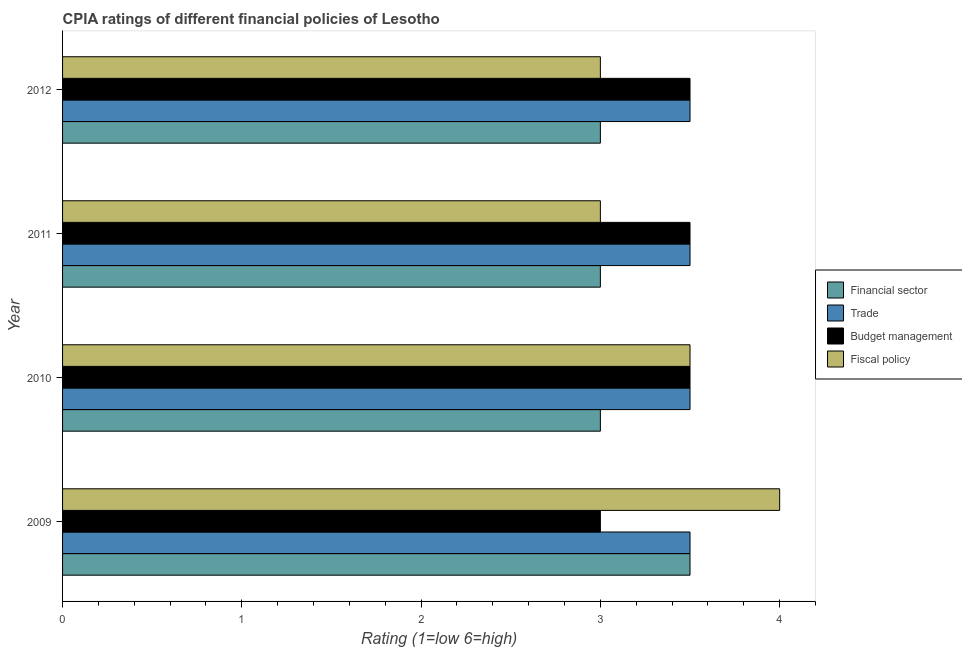How many different coloured bars are there?
Give a very brief answer. 4. How many groups of bars are there?
Your response must be concise. 4. Are the number of bars on each tick of the Y-axis equal?
Ensure brevity in your answer.  Yes. How many bars are there on the 2nd tick from the top?
Keep it short and to the point. 4. How many bars are there on the 1st tick from the bottom?
Provide a succinct answer. 4. In how many cases, is the number of bars for a given year not equal to the number of legend labels?
Offer a very short reply. 0. What is the cpia rating of trade in 2009?
Give a very brief answer. 3.5. Across all years, what is the maximum cpia rating of trade?
Offer a very short reply. 3.5. What is the difference between the cpia rating of financial sector in 2010 and that in 2011?
Provide a succinct answer. 0. What is the difference between the cpia rating of financial sector in 2009 and the cpia rating of trade in 2010?
Provide a short and direct response. 0. What is the average cpia rating of fiscal policy per year?
Provide a succinct answer. 3.38. What is the ratio of the cpia rating of fiscal policy in 2009 to that in 2010?
Ensure brevity in your answer.  1.14. Is the cpia rating of budget management in 2010 less than that in 2011?
Keep it short and to the point. No. In how many years, is the cpia rating of fiscal policy greater than the average cpia rating of fiscal policy taken over all years?
Your answer should be compact. 2. Is the sum of the cpia rating of fiscal policy in 2009 and 2011 greater than the maximum cpia rating of financial sector across all years?
Provide a succinct answer. Yes. Is it the case that in every year, the sum of the cpia rating of financial sector and cpia rating of fiscal policy is greater than the sum of cpia rating of budget management and cpia rating of trade?
Provide a succinct answer. No. What does the 3rd bar from the top in 2010 represents?
Your answer should be very brief. Trade. What does the 3rd bar from the bottom in 2011 represents?
Give a very brief answer. Budget management. How many bars are there?
Keep it short and to the point. 16. How many years are there in the graph?
Give a very brief answer. 4. Does the graph contain any zero values?
Your answer should be compact. No. What is the title of the graph?
Your response must be concise. CPIA ratings of different financial policies of Lesotho. Does "Primary education" appear as one of the legend labels in the graph?
Give a very brief answer. No. What is the label or title of the Y-axis?
Give a very brief answer. Year. What is the Rating (1=low 6=high) in Financial sector in 2009?
Give a very brief answer. 3.5. What is the Rating (1=low 6=high) of Trade in 2009?
Offer a very short reply. 3.5. What is the Rating (1=low 6=high) in Budget management in 2009?
Keep it short and to the point. 3. What is the Rating (1=low 6=high) in Financial sector in 2010?
Offer a very short reply. 3. What is the Rating (1=low 6=high) in Trade in 2010?
Offer a terse response. 3.5. What is the Rating (1=low 6=high) of Budget management in 2010?
Provide a succinct answer. 3.5. What is the Rating (1=low 6=high) in Financial sector in 2011?
Provide a short and direct response. 3. What is the Rating (1=low 6=high) in Budget management in 2011?
Offer a very short reply. 3.5. What is the Rating (1=low 6=high) of Financial sector in 2012?
Provide a succinct answer. 3. What is the Rating (1=low 6=high) in Trade in 2012?
Your answer should be compact. 3.5. Across all years, what is the maximum Rating (1=low 6=high) of Trade?
Make the answer very short. 3.5. Across all years, what is the maximum Rating (1=low 6=high) of Fiscal policy?
Keep it short and to the point. 4. Across all years, what is the minimum Rating (1=low 6=high) in Financial sector?
Offer a very short reply. 3. Across all years, what is the minimum Rating (1=low 6=high) in Trade?
Offer a very short reply. 3.5. Across all years, what is the minimum Rating (1=low 6=high) in Fiscal policy?
Your answer should be very brief. 3. What is the total Rating (1=low 6=high) in Budget management in the graph?
Give a very brief answer. 13.5. What is the total Rating (1=low 6=high) of Fiscal policy in the graph?
Give a very brief answer. 13.5. What is the difference between the Rating (1=low 6=high) in Trade in 2009 and that in 2010?
Ensure brevity in your answer.  0. What is the difference between the Rating (1=low 6=high) of Budget management in 2009 and that in 2010?
Ensure brevity in your answer.  -0.5. What is the difference between the Rating (1=low 6=high) in Fiscal policy in 2009 and that in 2011?
Make the answer very short. 1. What is the difference between the Rating (1=low 6=high) in Trade in 2009 and that in 2012?
Make the answer very short. 0. What is the difference between the Rating (1=low 6=high) of Budget management in 2009 and that in 2012?
Your answer should be very brief. -0.5. What is the difference between the Rating (1=low 6=high) in Financial sector in 2010 and that in 2011?
Keep it short and to the point. 0. What is the difference between the Rating (1=low 6=high) of Fiscal policy in 2010 and that in 2011?
Your response must be concise. 0.5. What is the difference between the Rating (1=low 6=high) in Trade in 2010 and that in 2012?
Provide a short and direct response. 0. What is the difference between the Rating (1=low 6=high) of Budget management in 2010 and that in 2012?
Keep it short and to the point. 0. What is the difference between the Rating (1=low 6=high) of Financial sector in 2011 and that in 2012?
Keep it short and to the point. 0. What is the difference between the Rating (1=low 6=high) of Trade in 2011 and that in 2012?
Offer a terse response. 0. What is the difference between the Rating (1=low 6=high) in Budget management in 2011 and that in 2012?
Keep it short and to the point. 0. What is the difference between the Rating (1=low 6=high) in Financial sector in 2009 and the Rating (1=low 6=high) in Budget management in 2010?
Keep it short and to the point. 0. What is the difference between the Rating (1=low 6=high) in Trade in 2009 and the Rating (1=low 6=high) in Budget management in 2010?
Ensure brevity in your answer.  0. What is the difference between the Rating (1=low 6=high) of Trade in 2009 and the Rating (1=low 6=high) of Budget management in 2011?
Your answer should be compact. 0. What is the difference between the Rating (1=low 6=high) in Trade in 2009 and the Rating (1=low 6=high) in Fiscal policy in 2011?
Your answer should be very brief. 0.5. What is the difference between the Rating (1=low 6=high) of Budget management in 2009 and the Rating (1=low 6=high) of Fiscal policy in 2011?
Ensure brevity in your answer.  0. What is the difference between the Rating (1=low 6=high) of Financial sector in 2009 and the Rating (1=low 6=high) of Trade in 2012?
Provide a succinct answer. 0. What is the difference between the Rating (1=low 6=high) in Financial sector in 2009 and the Rating (1=low 6=high) in Budget management in 2012?
Provide a short and direct response. 0. What is the difference between the Rating (1=low 6=high) in Financial sector in 2009 and the Rating (1=low 6=high) in Fiscal policy in 2012?
Provide a short and direct response. 0.5. What is the difference between the Rating (1=low 6=high) in Trade in 2009 and the Rating (1=low 6=high) in Budget management in 2012?
Provide a short and direct response. 0. What is the difference between the Rating (1=low 6=high) of Trade in 2009 and the Rating (1=low 6=high) of Fiscal policy in 2012?
Keep it short and to the point. 0.5. What is the difference between the Rating (1=low 6=high) in Budget management in 2009 and the Rating (1=low 6=high) in Fiscal policy in 2012?
Keep it short and to the point. 0. What is the difference between the Rating (1=low 6=high) of Trade in 2010 and the Rating (1=low 6=high) of Budget management in 2011?
Make the answer very short. 0. What is the difference between the Rating (1=low 6=high) in Financial sector in 2010 and the Rating (1=low 6=high) in Budget management in 2012?
Your response must be concise. -0.5. What is the difference between the Rating (1=low 6=high) of Financial sector in 2010 and the Rating (1=low 6=high) of Fiscal policy in 2012?
Ensure brevity in your answer.  0. What is the difference between the Rating (1=low 6=high) of Trade in 2010 and the Rating (1=low 6=high) of Budget management in 2012?
Make the answer very short. 0. What is the difference between the Rating (1=low 6=high) of Trade in 2010 and the Rating (1=low 6=high) of Fiscal policy in 2012?
Ensure brevity in your answer.  0.5. What is the difference between the Rating (1=low 6=high) of Financial sector in 2011 and the Rating (1=low 6=high) of Trade in 2012?
Make the answer very short. -0.5. What is the difference between the Rating (1=low 6=high) in Financial sector in 2011 and the Rating (1=low 6=high) in Budget management in 2012?
Provide a succinct answer. -0.5. What is the difference between the Rating (1=low 6=high) of Budget management in 2011 and the Rating (1=low 6=high) of Fiscal policy in 2012?
Your answer should be compact. 0.5. What is the average Rating (1=low 6=high) of Financial sector per year?
Provide a short and direct response. 3.12. What is the average Rating (1=low 6=high) of Trade per year?
Ensure brevity in your answer.  3.5. What is the average Rating (1=low 6=high) in Budget management per year?
Provide a succinct answer. 3.38. What is the average Rating (1=low 6=high) in Fiscal policy per year?
Make the answer very short. 3.38. In the year 2009, what is the difference between the Rating (1=low 6=high) of Financial sector and Rating (1=low 6=high) of Trade?
Give a very brief answer. 0. In the year 2009, what is the difference between the Rating (1=low 6=high) in Financial sector and Rating (1=low 6=high) in Budget management?
Your answer should be compact. 0.5. In the year 2009, what is the difference between the Rating (1=low 6=high) of Trade and Rating (1=low 6=high) of Budget management?
Your response must be concise. 0.5. In the year 2009, what is the difference between the Rating (1=low 6=high) in Trade and Rating (1=low 6=high) in Fiscal policy?
Give a very brief answer. -0.5. In the year 2010, what is the difference between the Rating (1=low 6=high) of Trade and Rating (1=low 6=high) of Budget management?
Give a very brief answer. 0. In the year 2010, what is the difference between the Rating (1=low 6=high) in Trade and Rating (1=low 6=high) in Fiscal policy?
Offer a terse response. 0. In the year 2010, what is the difference between the Rating (1=low 6=high) of Budget management and Rating (1=low 6=high) of Fiscal policy?
Make the answer very short. 0. In the year 2011, what is the difference between the Rating (1=low 6=high) of Financial sector and Rating (1=low 6=high) of Fiscal policy?
Keep it short and to the point. 0. In the year 2012, what is the difference between the Rating (1=low 6=high) of Financial sector and Rating (1=low 6=high) of Trade?
Ensure brevity in your answer.  -0.5. In the year 2012, what is the difference between the Rating (1=low 6=high) in Trade and Rating (1=low 6=high) in Fiscal policy?
Give a very brief answer. 0.5. In the year 2012, what is the difference between the Rating (1=low 6=high) of Budget management and Rating (1=low 6=high) of Fiscal policy?
Your answer should be very brief. 0.5. What is the ratio of the Rating (1=low 6=high) of Trade in 2009 to that in 2010?
Give a very brief answer. 1. What is the ratio of the Rating (1=low 6=high) of Budget management in 2009 to that in 2011?
Your answer should be compact. 0.86. What is the ratio of the Rating (1=low 6=high) in Financial sector in 2009 to that in 2012?
Your answer should be compact. 1.17. What is the ratio of the Rating (1=low 6=high) of Trade in 2009 to that in 2012?
Provide a short and direct response. 1. What is the ratio of the Rating (1=low 6=high) in Trade in 2010 to that in 2011?
Your answer should be compact. 1. What is the ratio of the Rating (1=low 6=high) of Budget management in 2010 to that in 2011?
Offer a very short reply. 1. What is the ratio of the Rating (1=low 6=high) in Fiscal policy in 2010 to that in 2011?
Give a very brief answer. 1.17. What is the ratio of the Rating (1=low 6=high) in Financial sector in 2010 to that in 2012?
Offer a terse response. 1. What is the ratio of the Rating (1=low 6=high) in Trade in 2010 to that in 2012?
Your response must be concise. 1. What is the ratio of the Rating (1=low 6=high) of Budget management in 2010 to that in 2012?
Give a very brief answer. 1. What is the ratio of the Rating (1=low 6=high) in Fiscal policy in 2010 to that in 2012?
Make the answer very short. 1.17. What is the ratio of the Rating (1=low 6=high) of Financial sector in 2011 to that in 2012?
Your answer should be compact. 1. What is the ratio of the Rating (1=low 6=high) in Trade in 2011 to that in 2012?
Your response must be concise. 1. What is the difference between the highest and the second highest Rating (1=low 6=high) in Trade?
Your response must be concise. 0. What is the difference between the highest and the second highest Rating (1=low 6=high) of Fiscal policy?
Keep it short and to the point. 0.5. What is the difference between the highest and the lowest Rating (1=low 6=high) in Financial sector?
Make the answer very short. 0.5. 